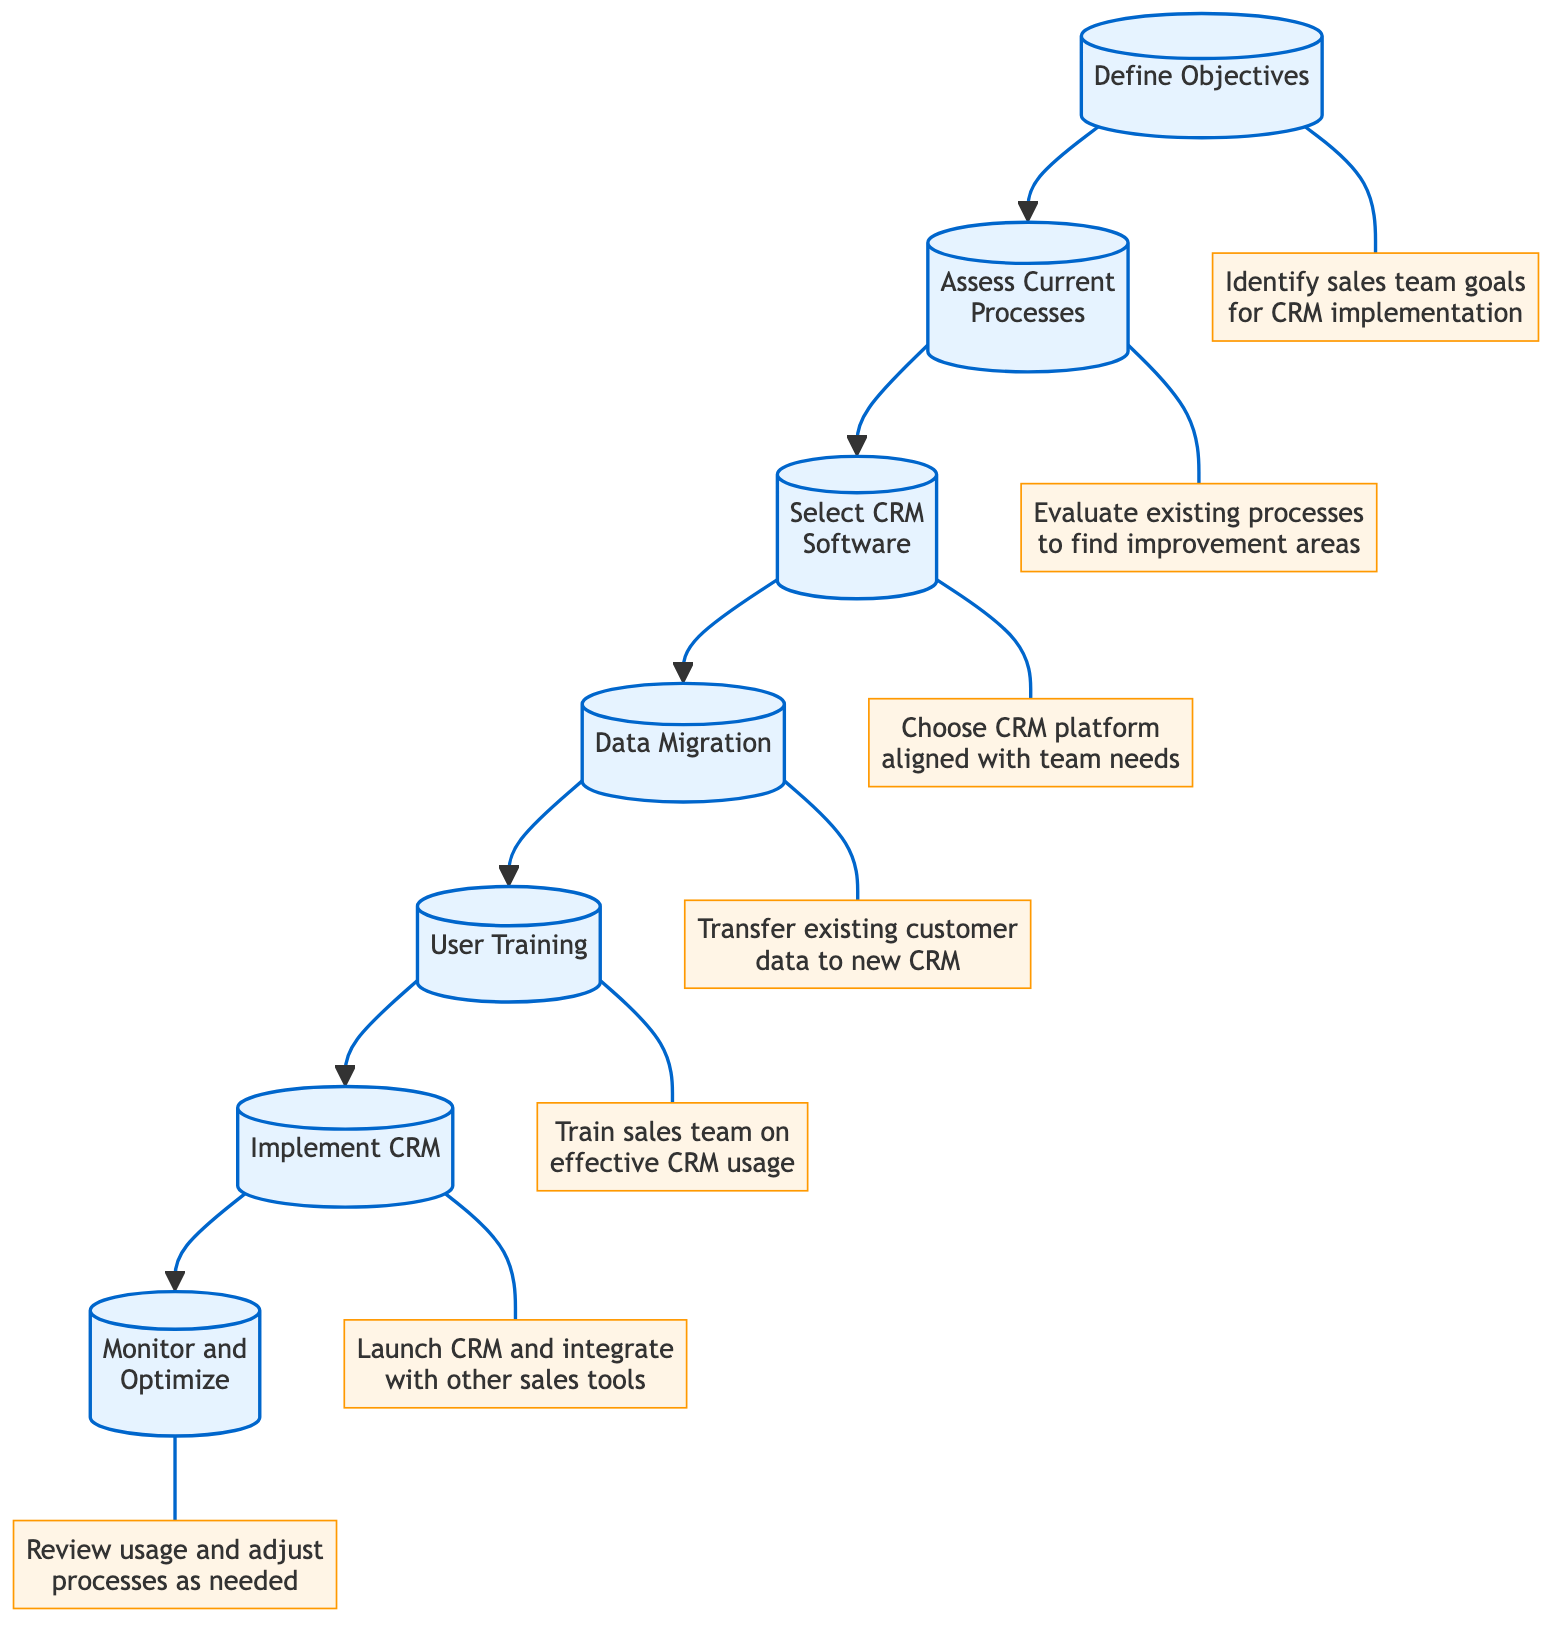What is the first step in the CRM implementation process? The first step in the flow chart shows "Define Objectives," which indicates the initial action in the implementation process.
Answer: Define Objectives How many steps are involved in the CRM implementation? By counting the nodes depicted in the flow chart, there are a total of 7 steps outlined for the CRM implementation process.
Answer: 7 What step comes after "Data Migration"? According to the flow of the diagram, the step that follows "Data Migration" is "User Training."
Answer: User Training What is the main objective of "Monitor and Optimize"? The purpose of "Monitor and Optimize" is to regularly review CRM usage and adjust processes to ensure maximum efficiency, as indicated in the description connected to this step.
Answer: Review usage and adjust processes Which step involves training the sales team? The step labeled "User Training" is specifically about providing training for the sales team on the effective use of the CRM system, as shown in the diagram.
Answer: User Training What is the relationship between "Select CRM Software" and "Data Migration"? The flow chart shows a direct connection from "Select CRM Software" to "Data Migration," indicating that selecting the software is a prerequisite for migrating data into the new system.
Answer: Direct connection What does "Define Objectives" prioritize for the sales team? The description associated with "Define Objectives" highlights identifying what the sales team aims to achieve with the CRM, such as improving lead tracking and enhancing customer relationships.
Answer: Identify sales team goals After "Implement CRM," what step follows? The diagram flows from "Implement CRM" to "Monitor and Optimize," indicating that once the CRM is implemented, the next step is to monitor and enhance its use.
Answer: Monitor and Optimize What does the "Data Migration" step involve? According to the flow chart, "Data Migration" refers to planning and executing the transfer of existing customer data into the new CRM system, which ensures that valuable information is retained.
Answer: Transfer existing customer data 